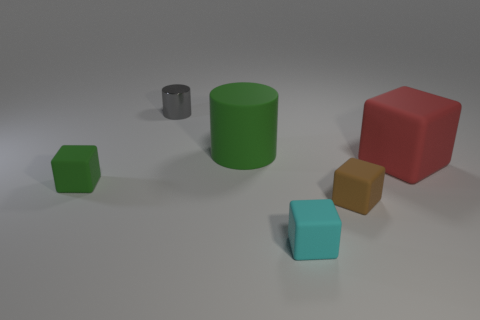There is a green thing that is to the right of the small gray thing; does it have the same shape as the tiny brown object?
Make the answer very short. No. How many objects are either small rubber cubes that are on the left side of the brown rubber object or things behind the red rubber cube?
Ensure brevity in your answer.  4. There is another big object that is the same shape as the brown rubber thing; what is its color?
Give a very brief answer. Red. Are there any other things that are the same shape as the big red matte thing?
Your answer should be compact. Yes. There is a metallic object; is its shape the same as the tiny thing on the left side of the gray metallic thing?
Keep it short and to the point. No. What is the green block made of?
Your answer should be compact. Rubber. What size is the cyan matte object that is the same shape as the tiny green thing?
Keep it short and to the point. Small. What number of other objects are there of the same material as the small brown cube?
Provide a short and direct response. 4. Is the big green cylinder made of the same material as the tiny cube that is on the left side of the small shiny cylinder?
Keep it short and to the point. Yes. Are there fewer cylinders that are in front of the small cyan cube than tiny brown matte objects behind the small gray cylinder?
Offer a terse response. No. 